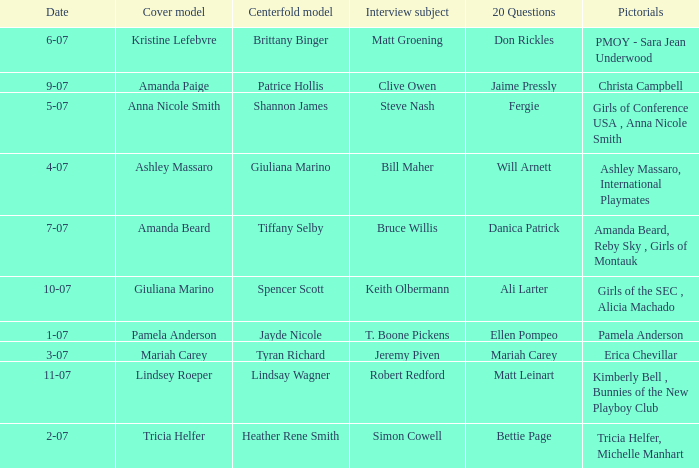List the pictorals from issues when lindsey roeper was the cover model. Kimberly Bell , Bunnies of the New Playboy Club. 